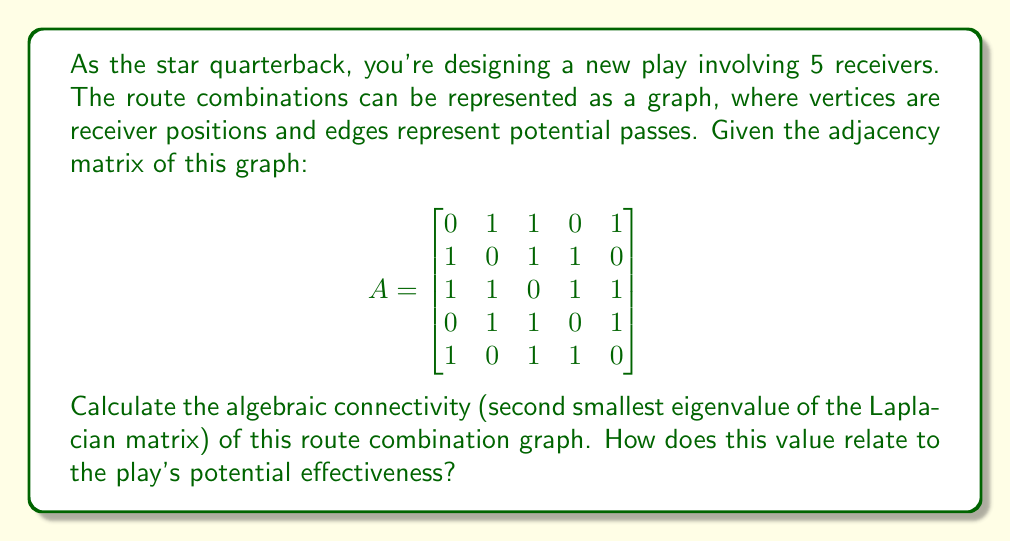Could you help me with this problem? To solve this problem, we'll follow these steps:

1) First, we need to calculate the Laplacian matrix $L$ from the adjacency matrix $A$. The Laplacian matrix is defined as $L = D - A$, where $D$ is the degree matrix.

2) To get the degree matrix, we sum each row of $A$:
   $$D = \text{diag}(3, 3, 4, 3, 3)$$

3) Now we can calculate $L$:
   $$L = D - A = \begin{bmatrix}
   3 & -1 & -1 & 0 & -1 \\
   -1 & 3 & -1 & -1 & 0 \\
   -1 & -1 & 4 & -1 & -1 \\
   0 & -1 & -1 & 3 & -1 \\
   -1 & 0 & -1 & -1 & 3
   \end{bmatrix}$$

4) We need to find the eigenvalues of $L$. Using a computer algebra system or numerical methods, we get:
   $$\lambda_1 = 0, \lambda_2 \approx 0.7639, \lambda_3 \approx 2.6889, \lambda_4 \approx 3.7639, \lambda_5 \approx 4.7834$$

5) The algebraic connectivity is the second smallest eigenvalue, which is $\lambda_2 \approx 0.7639$.

6) In graph spectral theory, higher algebraic connectivity indicates better connectivity and robustness of the graph. In the context of route combinations, this suggests:
   - The play has good overall connectivity, allowing for multiple passing options.
   - The routes are well-distributed, making it harder for the defense to predict and cover all options.
   - There's a balance between having multiple options (connectivity) and not overcrowding the field (which would be indicated by an even higher value).

This value suggests a potentially effective play design, offering you as the quarterback multiple viable passing options while maintaining a good spread of receivers.
Answer: $0.7639$; higher value indicates better connectivity and potentially more effective play design. 